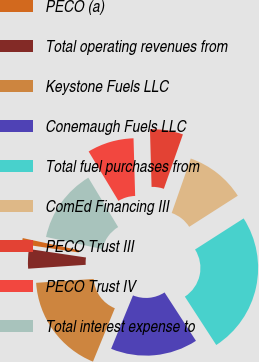Convert chart. <chart><loc_0><loc_0><loc_500><loc_500><pie_chart><fcel>PECO (a)<fcel>Total operating revenues from<fcel>Keystone Fuels LLC<fcel>Conemaugh Fuels LLC<fcel>Total fuel purchases from<fcel>ComEd Financing III<fcel>PECO Trust III<fcel>PECO Trust IV<fcel>Total interest expense to<nl><fcel>1.04%<fcel>3.42%<fcel>17.74%<fcel>15.35%<fcel>24.9%<fcel>10.58%<fcel>5.81%<fcel>8.2%<fcel>12.97%<nl></chart> 